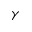Convert formula to latex. <formula><loc_0><loc_0><loc_500><loc_500>\gamma</formula> 